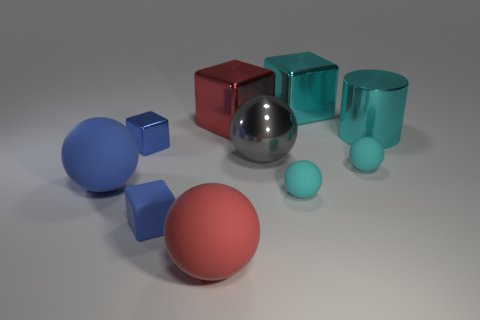Subtract all gray spheres. How many blue blocks are left? 2 Subtract 1 blocks. How many blocks are left? 3 Subtract all matte blocks. How many blocks are left? 3 Subtract all cyan cubes. How many cubes are left? 3 Subtract all blocks. How many objects are left? 6 Subtract all yellow cubes. Subtract all yellow cylinders. How many cubes are left? 4 Add 3 red matte objects. How many red matte objects are left? 4 Add 1 blue shiny blocks. How many blue shiny blocks exist? 2 Subtract 0 purple balls. How many objects are left? 10 Subtract all big objects. Subtract all large gray metallic balls. How many objects are left? 3 